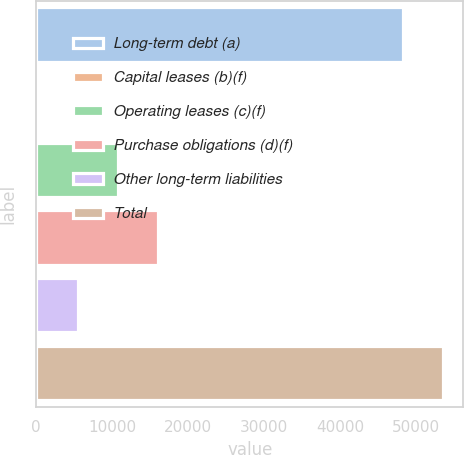Convert chart to OTSL. <chart><loc_0><loc_0><loc_500><loc_500><bar_chart><fcel>Long-term debt (a)<fcel>Capital leases (b)(f)<fcel>Operating leases (c)(f)<fcel>Purchase obligations (d)(f)<fcel>Other long-term liabilities<fcel>Total<nl><fcel>48251<fcel>237<fcel>10800<fcel>16081.5<fcel>5518.5<fcel>53532.5<nl></chart> 